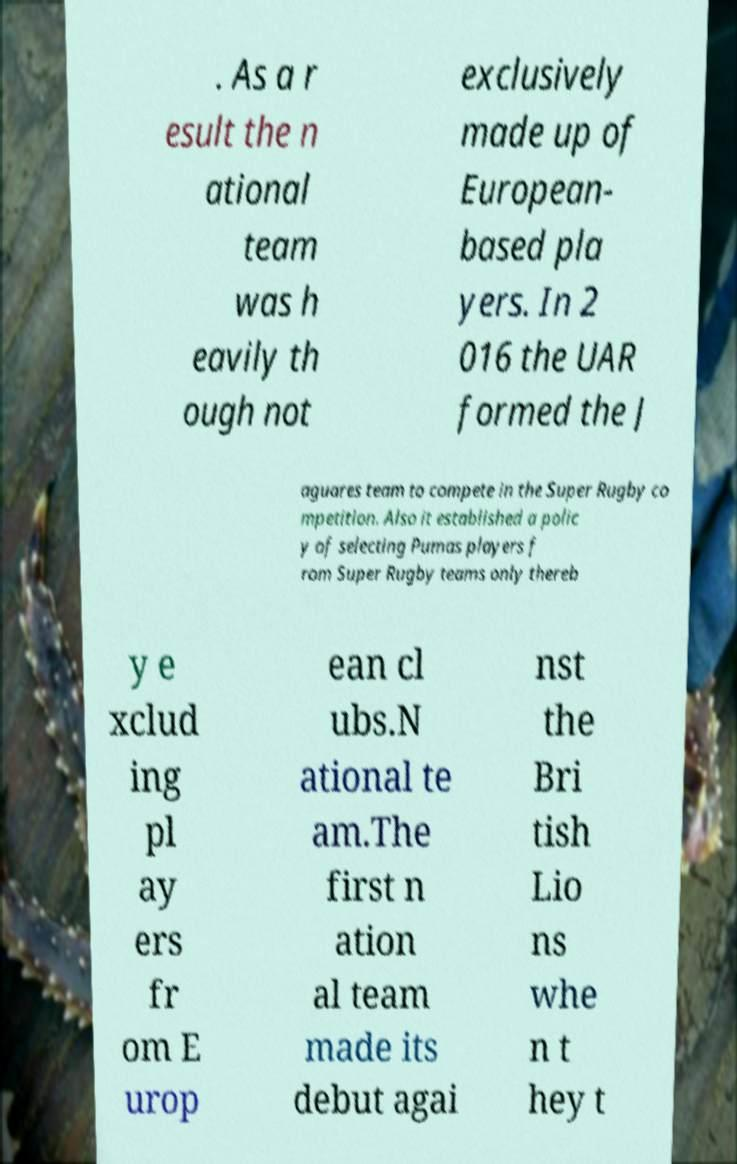Could you extract and type out the text from this image? . As a r esult the n ational team was h eavily th ough not exclusively made up of European- based pla yers. In 2 016 the UAR formed the J aguares team to compete in the Super Rugby co mpetition. Also it established a polic y of selecting Pumas players f rom Super Rugby teams only thereb y e xclud ing pl ay ers fr om E urop ean cl ubs.N ational te am.The first n ation al team made its debut agai nst the Bri tish Lio ns whe n t hey t 